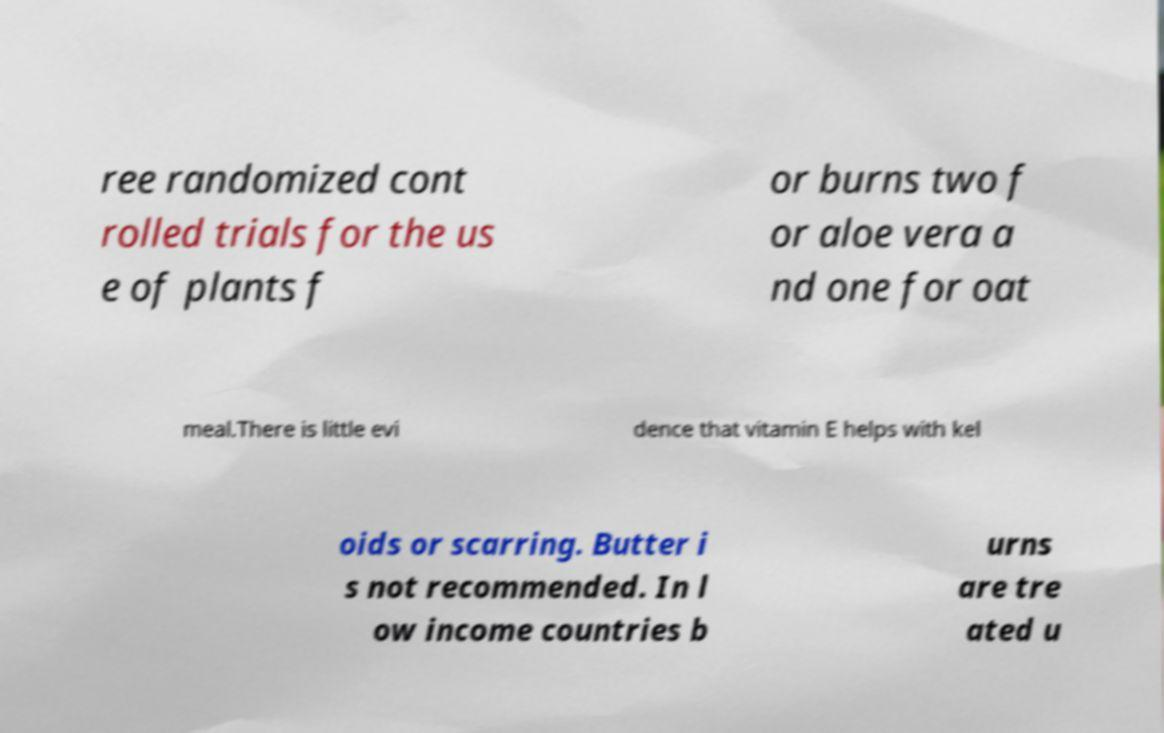Please read and relay the text visible in this image. What does it say? ree randomized cont rolled trials for the us e of plants f or burns two f or aloe vera a nd one for oat meal.There is little evi dence that vitamin E helps with kel oids or scarring. Butter i s not recommended. In l ow income countries b urns are tre ated u 